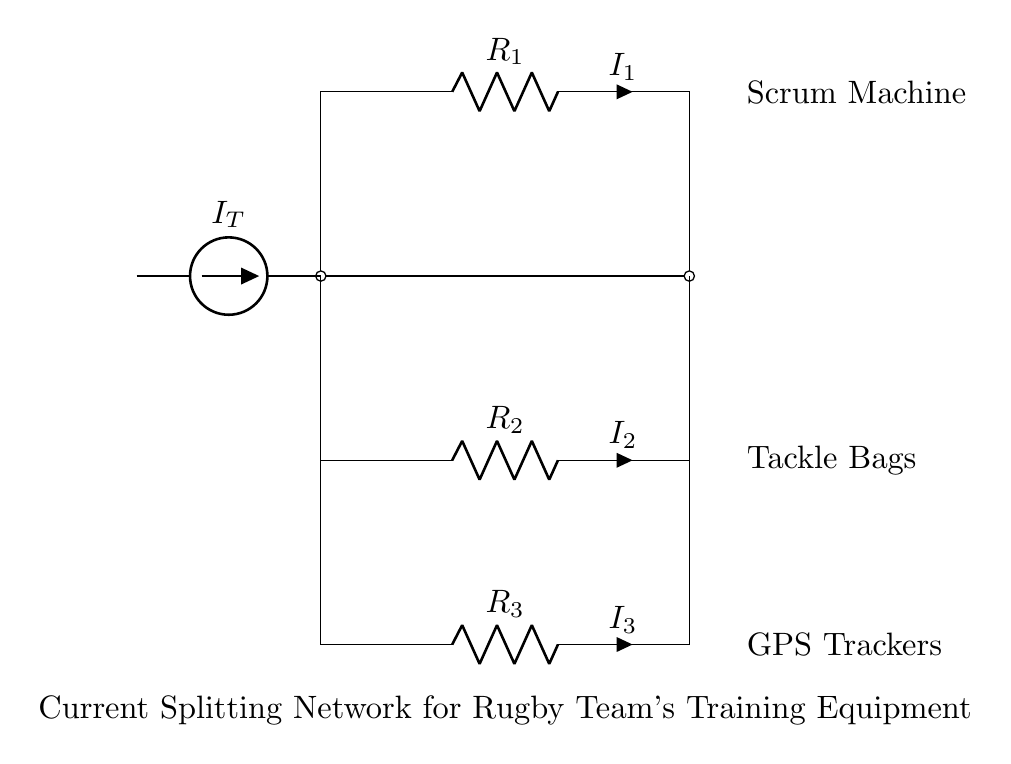What does the symbol at the left represent? The symbol at the left represents a current source, specifically an American current source labeled as I_T. It indicates the total current entering the current splitting network circuit.
Answer: Current source How many resistors are shown in the circuit diagram? There are three resistors labeled R_1, R_2, and R_3, representing the different loads in the current splitting network. Each resistor corresponds to a specific piece of training equipment.
Answer: Three What is the purpose of the R_1 resistor? The R_1 resistor is connected to the scrum machine, which indicates it represents the load impedance related to that equipment. Since it is part of the current divider, it will affect the distribution of current through the network.
Answer: Scrum machine What type of circuit is portrayed in this diagram? The circuit depicted is a current divider, which is characteristic of a network where an input current is split among multiple branches that each contain resistive elements.
Answer: Current divider If the total current I_T is five amps, how much current flows through R_2, assuming equal resistance? If we assume R_1, R_2, and R_3 are equal, then the current through R_2 would be one-third of the total current since in parallel configuration, the current divides equally among the resistors. That is calculated as total current divided by the number of branches.
Answer: One point six seven amps Which equipment is connected to R_3? The equipment connected to R_3 is labeled as GPS trackers, indicating the specific application of this resistor in the current divider network.
Answer: GPS trackers 